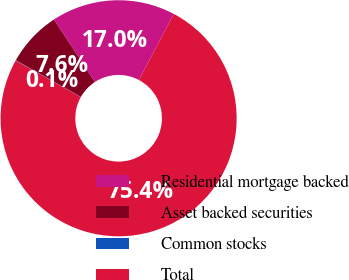Convert chart to OTSL. <chart><loc_0><loc_0><loc_500><loc_500><pie_chart><fcel>Residential mortgage backed<fcel>Asset backed securities<fcel>Common stocks<fcel>Total<nl><fcel>16.98%<fcel>7.59%<fcel>0.05%<fcel>75.38%<nl></chart> 